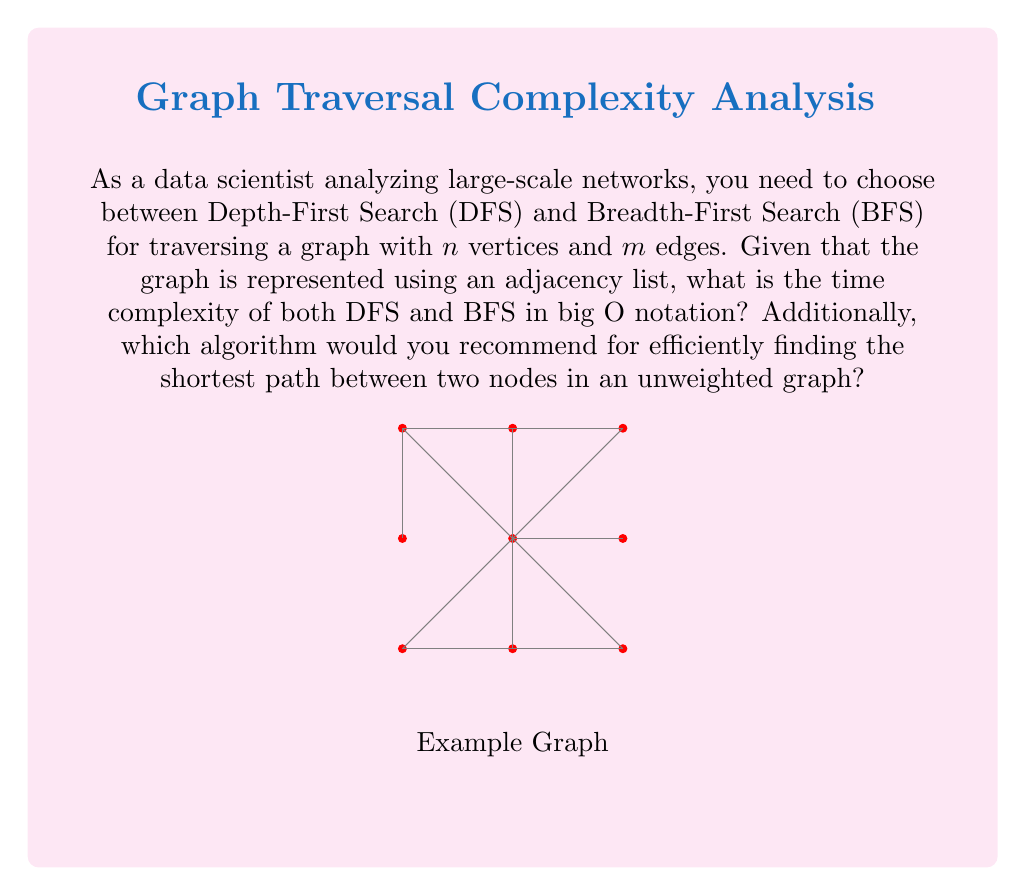Can you answer this question? To determine the time complexity of DFS and BFS for a graph with $n$ vertices and $m$ edges, we need to consider the operations performed during the traversal:

1. For both DFS and BFS:
   - Each vertex is visited once: $O(n)$
   - Each edge is explored once: $O(m)$

2. Using an adjacency list representation:
   - Accessing adjacent vertices takes $O(1)$ time for each vertex

3. DFS typically uses a stack (or recursion), while BFS uses a queue:
   - Push and pop operations for both data structures take $O(1)$ time

4. Time complexity calculation:
   $$O(n + m)$$ for both DFS and BFS

   This is because we visit each vertex once and explore each edge once.

5. For finding the shortest path in an unweighted graph:
   - BFS is preferred because it explores nodes level by level
   - It guarantees finding the shortest path in terms of the number of edges
   - DFS may find a path, but it's not guaranteed to be the shortest

6. Space complexity:
   - Both algorithms have a space complexity of $O(n)$ in the worst case
   - This accounts for the stack/queue and visited node tracking

Therefore, both DFS and BFS have a time complexity of $O(n + m)$, but BFS is recommended for finding the shortest path in an unweighted graph due to its level-wise exploration strategy.
Answer: Time complexity: $O(n + m)$ for both DFS and BFS. Recommend BFS for shortest path in unweighted graphs. 